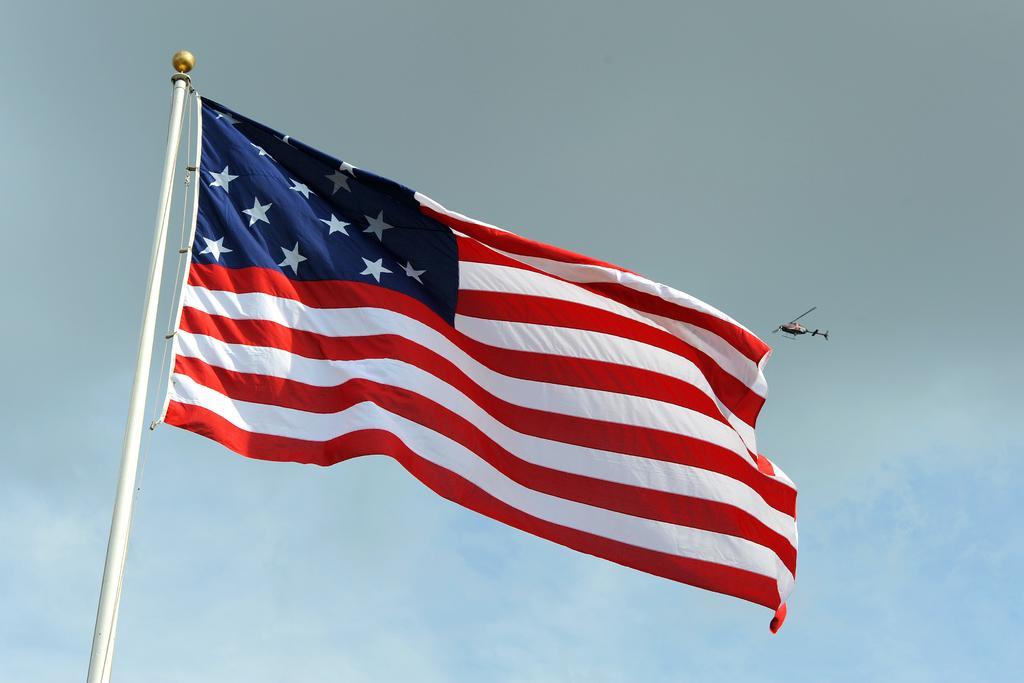Could you give a brief overview of what you see in this image? In this picture we can see a flag and we can see a helicopter flying and we can see sky in the background. 